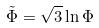Convert formula to latex. <formula><loc_0><loc_0><loc_500><loc_500>\tilde { \Phi } = \sqrt { 3 } \ln \Phi</formula> 